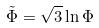Convert formula to latex. <formula><loc_0><loc_0><loc_500><loc_500>\tilde { \Phi } = \sqrt { 3 } \ln \Phi</formula> 